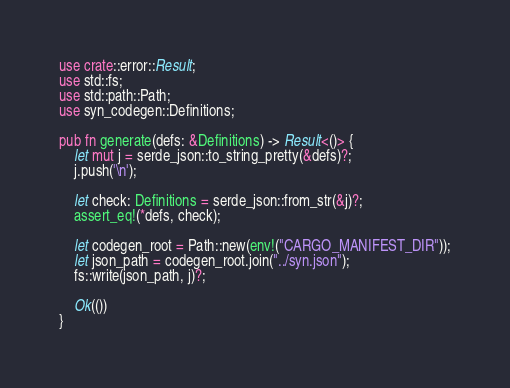Convert code to text. <code><loc_0><loc_0><loc_500><loc_500><_Rust_>use crate::error::Result;
use std::fs;
use std::path::Path;
use syn_codegen::Definitions;

pub fn generate(defs: &Definitions) -> Result<()> {
    let mut j = serde_json::to_string_pretty(&defs)?;
    j.push('\n');

    let check: Definitions = serde_json::from_str(&j)?;
    assert_eq!(*defs, check);

    let codegen_root = Path::new(env!("CARGO_MANIFEST_DIR"));
    let json_path = codegen_root.join("../syn.json");
    fs::write(json_path, j)?;

    Ok(())
}
</code> 